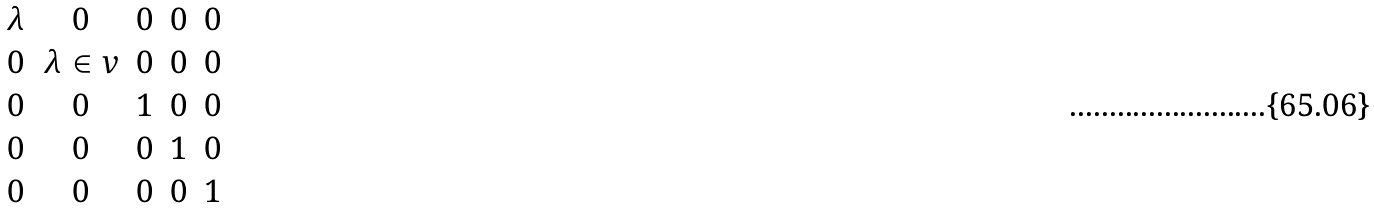<formula> <loc_0><loc_0><loc_500><loc_500>\begin{matrix} \lambda & 0 & 0 & 0 & 0 \\ 0 & \lambda \in v & 0 & 0 & 0 \\ 0 & 0 & 1 & 0 & 0 \\ 0 & 0 & 0 & 1 & 0 \\ 0 & 0 & 0 & 0 & 1 \end{matrix}</formula> 